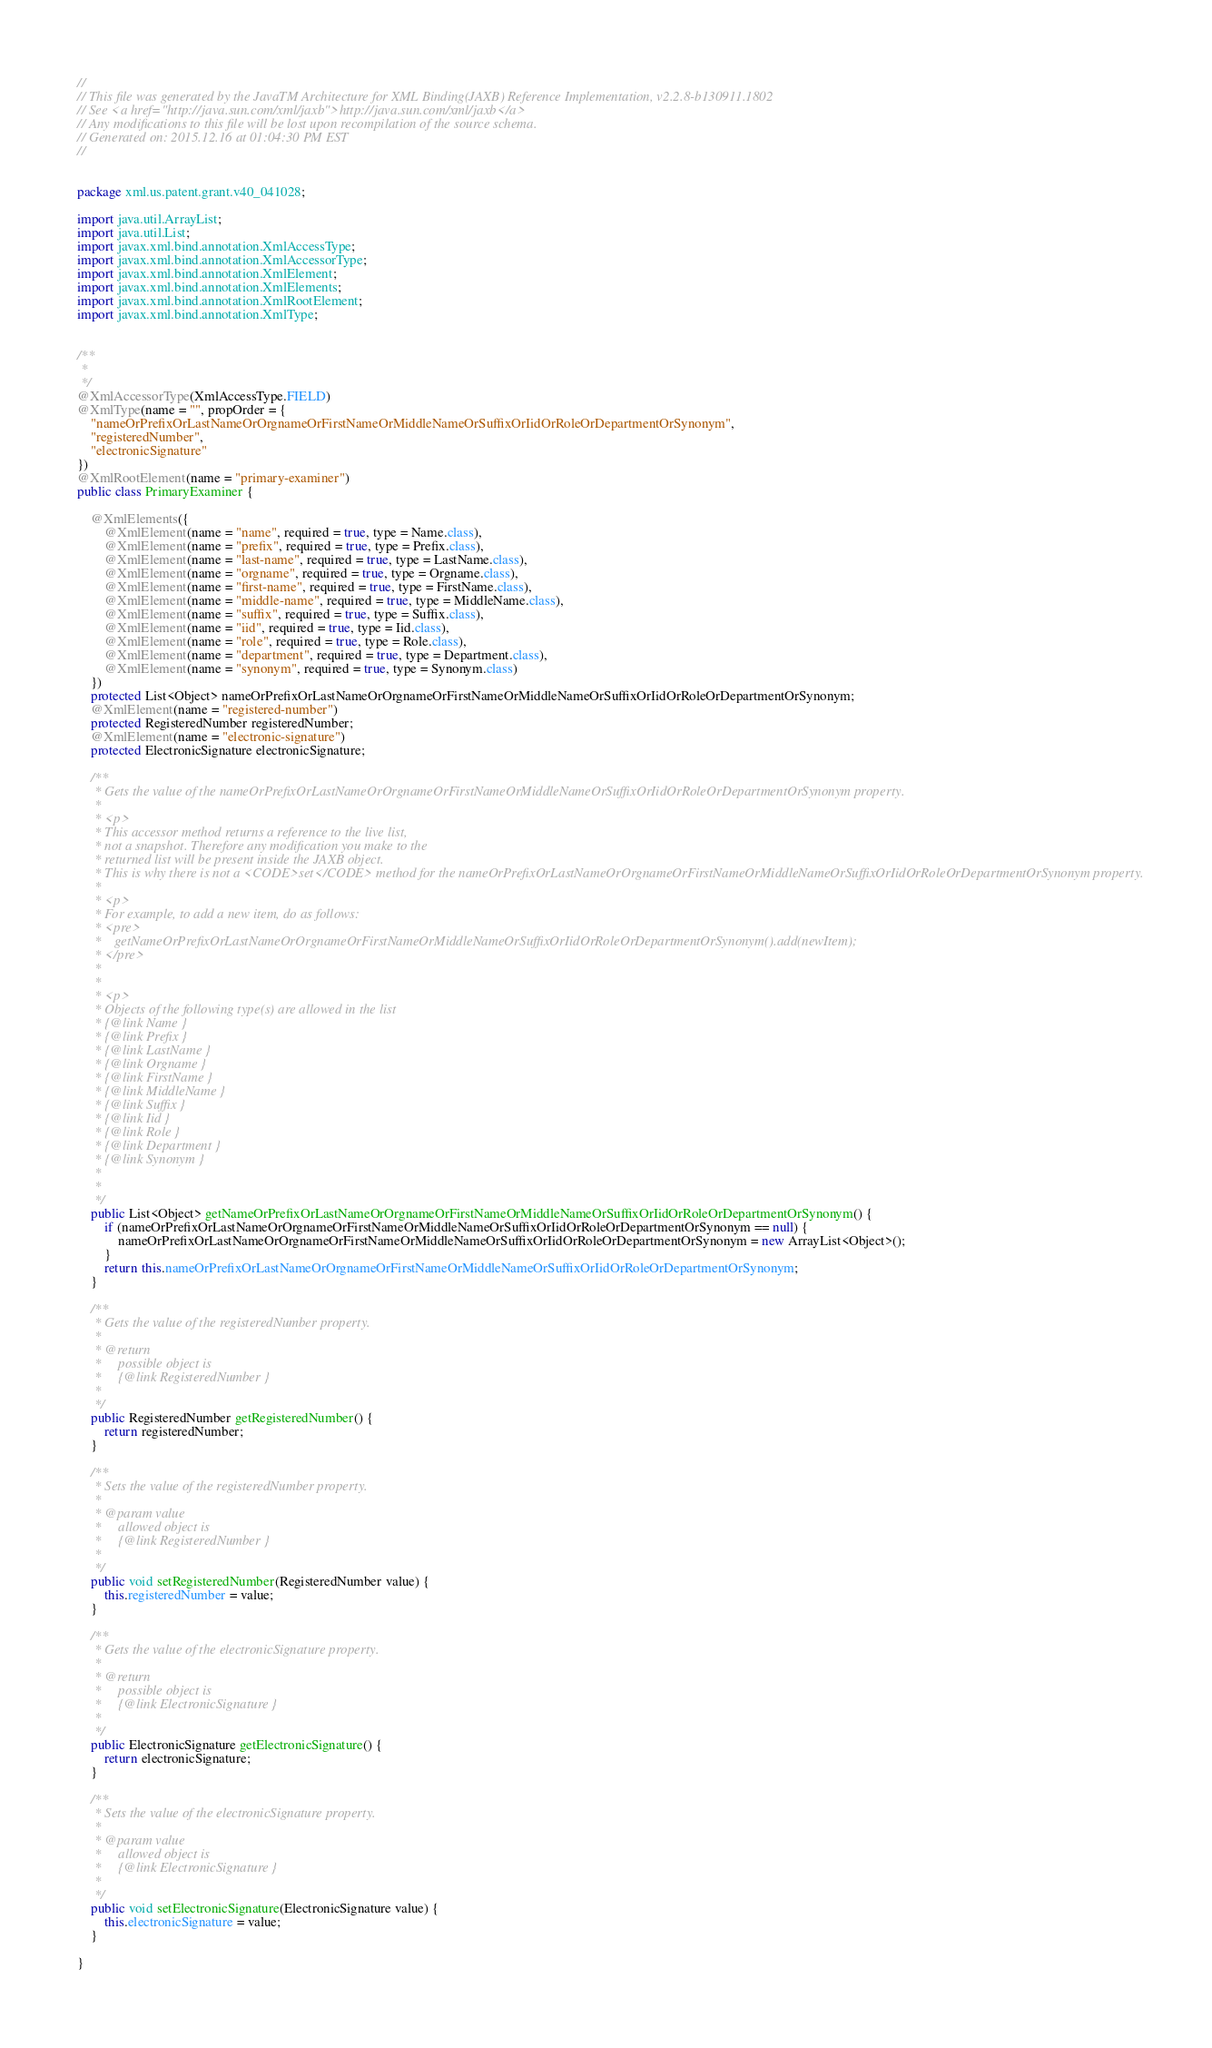Convert code to text. <code><loc_0><loc_0><loc_500><loc_500><_Java_>//
// This file was generated by the JavaTM Architecture for XML Binding(JAXB) Reference Implementation, v2.2.8-b130911.1802 
// See <a href="http://java.sun.com/xml/jaxb">http://java.sun.com/xml/jaxb</a> 
// Any modifications to this file will be lost upon recompilation of the source schema. 
// Generated on: 2015.12.16 at 01:04:30 PM EST 
//


package xml.us.patent.grant.v40_041028;

import java.util.ArrayList;
import java.util.List;
import javax.xml.bind.annotation.XmlAccessType;
import javax.xml.bind.annotation.XmlAccessorType;
import javax.xml.bind.annotation.XmlElement;
import javax.xml.bind.annotation.XmlElements;
import javax.xml.bind.annotation.XmlRootElement;
import javax.xml.bind.annotation.XmlType;


/**
 * 
 */
@XmlAccessorType(XmlAccessType.FIELD)
@XmlType(name = "", propOrder = {
    "nameOrPrefixOrLastNameOrOrgnameOrFirstNameOrMiddleNameOrSuffixOrIidOrRoleOrDepartmentOrSynonym",
    "registeredNumber",
    "electronicSignature"
})
@XmlRootElement(name = "primary-examiner")
public class PrimaryExaminer {

    @XmlElements({
        @XmlElement(name = "name", required = true, type = Name.class),
        @XmlElement(name = "prefix", required = true, type = Prefix.class),
        @XmlElement(name = "last-name", required = true, type = LastName.class),
        @XmlElement(name = "orgname", required = true, type = Orgname.class),
        @XmlElement(name = "first-name", required = true, type = FirstName.class),
        @XmlElement(name = "middle-name", required = true, type = MiddleName.class),
        @XmlElement(name = "suffix", required = true, type = Suffix.class),
        @XmlElement(name = "iid", required = true, type = Iid.class),
        @XmlElement(name = "role", required = true, type = Role.class),
        @XmlElement(name = "department", required = true, type = Department.class),
        @XmlElement(name = "synonym", required = true, type = Synonym.class)
    })
    protected List<Object> nameOrPrefixOrLastNameOrOrgnameOrFirstNameOrMiddleNameOrSuffixOrIidOrRoleOrDepartmentOrSynonym;
    @XmlElement(name = "registered-number")
    protected RegisteredNumber registeredNumber;
    @XmlElement(name = "electronic-signature")
    protected ElectronicSignature electronicSignature;

    /**
     * Gets the value of the nameOrPrefixOrLastNameOrOrgnameOrFirstNameOrMiddleNameOrSuffixOrIidOrRoleOrDepartmentOrSynonym property.
     * 
     * <p>
     * This accessor method returns a reference to the live list,
     * not a snapshot. Therefore any modification you make to the
     * returned list will be present inside the JAXB object.
     * This is why there is not a <CODE>set</CODE> method for the nameOrPrefixOrLastNameOrOrgnameOrFirstNameOrMiddleNameOrSuffixOrIidOrRoleOrDepartmentOrSynonym property.
     * 
     * <p>
     * For example, to add a new item, do as follows:
     * <pre>
     *    getNameOrPrefixOrLastNameOrOrgnameOrFirstNameOrMiddleNameOrSuffixOrIidOrRoleOrDepartmentOrSynonym().add(newItem);
     * </pre>
     * 
     * 
     * <p>
     * Objects of the following type(s) are allowed in the list
     * {@link Name }
     * {@link Prefix }
     * {@link LastName }
     * {@link Orgname }
     * {@link FirstName }
     * {@link MiddleName }
     * {@link Suffix }
     * {@link Iid }
     * {@link Role }
     * {@link Department }
     * {@link Synonym }
     * 
     * 
     */
    public List<Object> getNameOrPrefixOrLastNameOrOrgnameOrFirstNameOrMiddleNameOrSuffixOrIidOrRoleOrDepartmentOrSynonym() {
        if (nameOrPrefixOrLastNameOrOrgnameOrFirstNameOrMiddleNameOrSuffixOrIidOrRoleOrDepartmentOrSynonym == null) {
            nameOrPrefixOrLastNameOrOrgnameOrFirstNameOrMiddleNameOrSuffixOrIidOrRoleOrDepartmentOrSynonym = new ArrayList<Object>();
        }
        return this.nameOrPrefixOrLastNameOrOrgnameOrFirstNameOrMiddleNameOrSuffixOrIidOrRoleOrDepartmentOrSynonym;
    }

    /**
     * Gets the value of the registeredNumber property.
     * 
     * @return
     *     possible object is
     *     {@link RegisteredNumber }
     *     
     */
    public RegisteredNumber getRegisteredNumber() {
        return registeredNumber;
    }

    /**
     * Sets the value of the registeredNumber property.
     * 
     * @param value
     *     allowed object is
     *     {@link RegisteredNumber }
     *     
     */
    public void setRegisteredNumber(RegisteredNumber value) {
        this.registeredNumber = value;
    }

    /**
     * Gets the value of the electronicSignature property.
     * 
     * @return
     *     possible object is
     *     {@link ElectronicSignature }
     *     
     */
    public ElectronicSignature getElectronicSignature() {
        return electronicSignature;
    }

    /**
     * Sets the value of the electronicSignature property.
     * 
     * @param value
     *     allowed object is
     *     {@link ElectronicSignature }
     *     
     */
    public void setElectronicSignature(ElectronicSignature value) {
        this.electronicSignature = value;
    }

}
</code> 